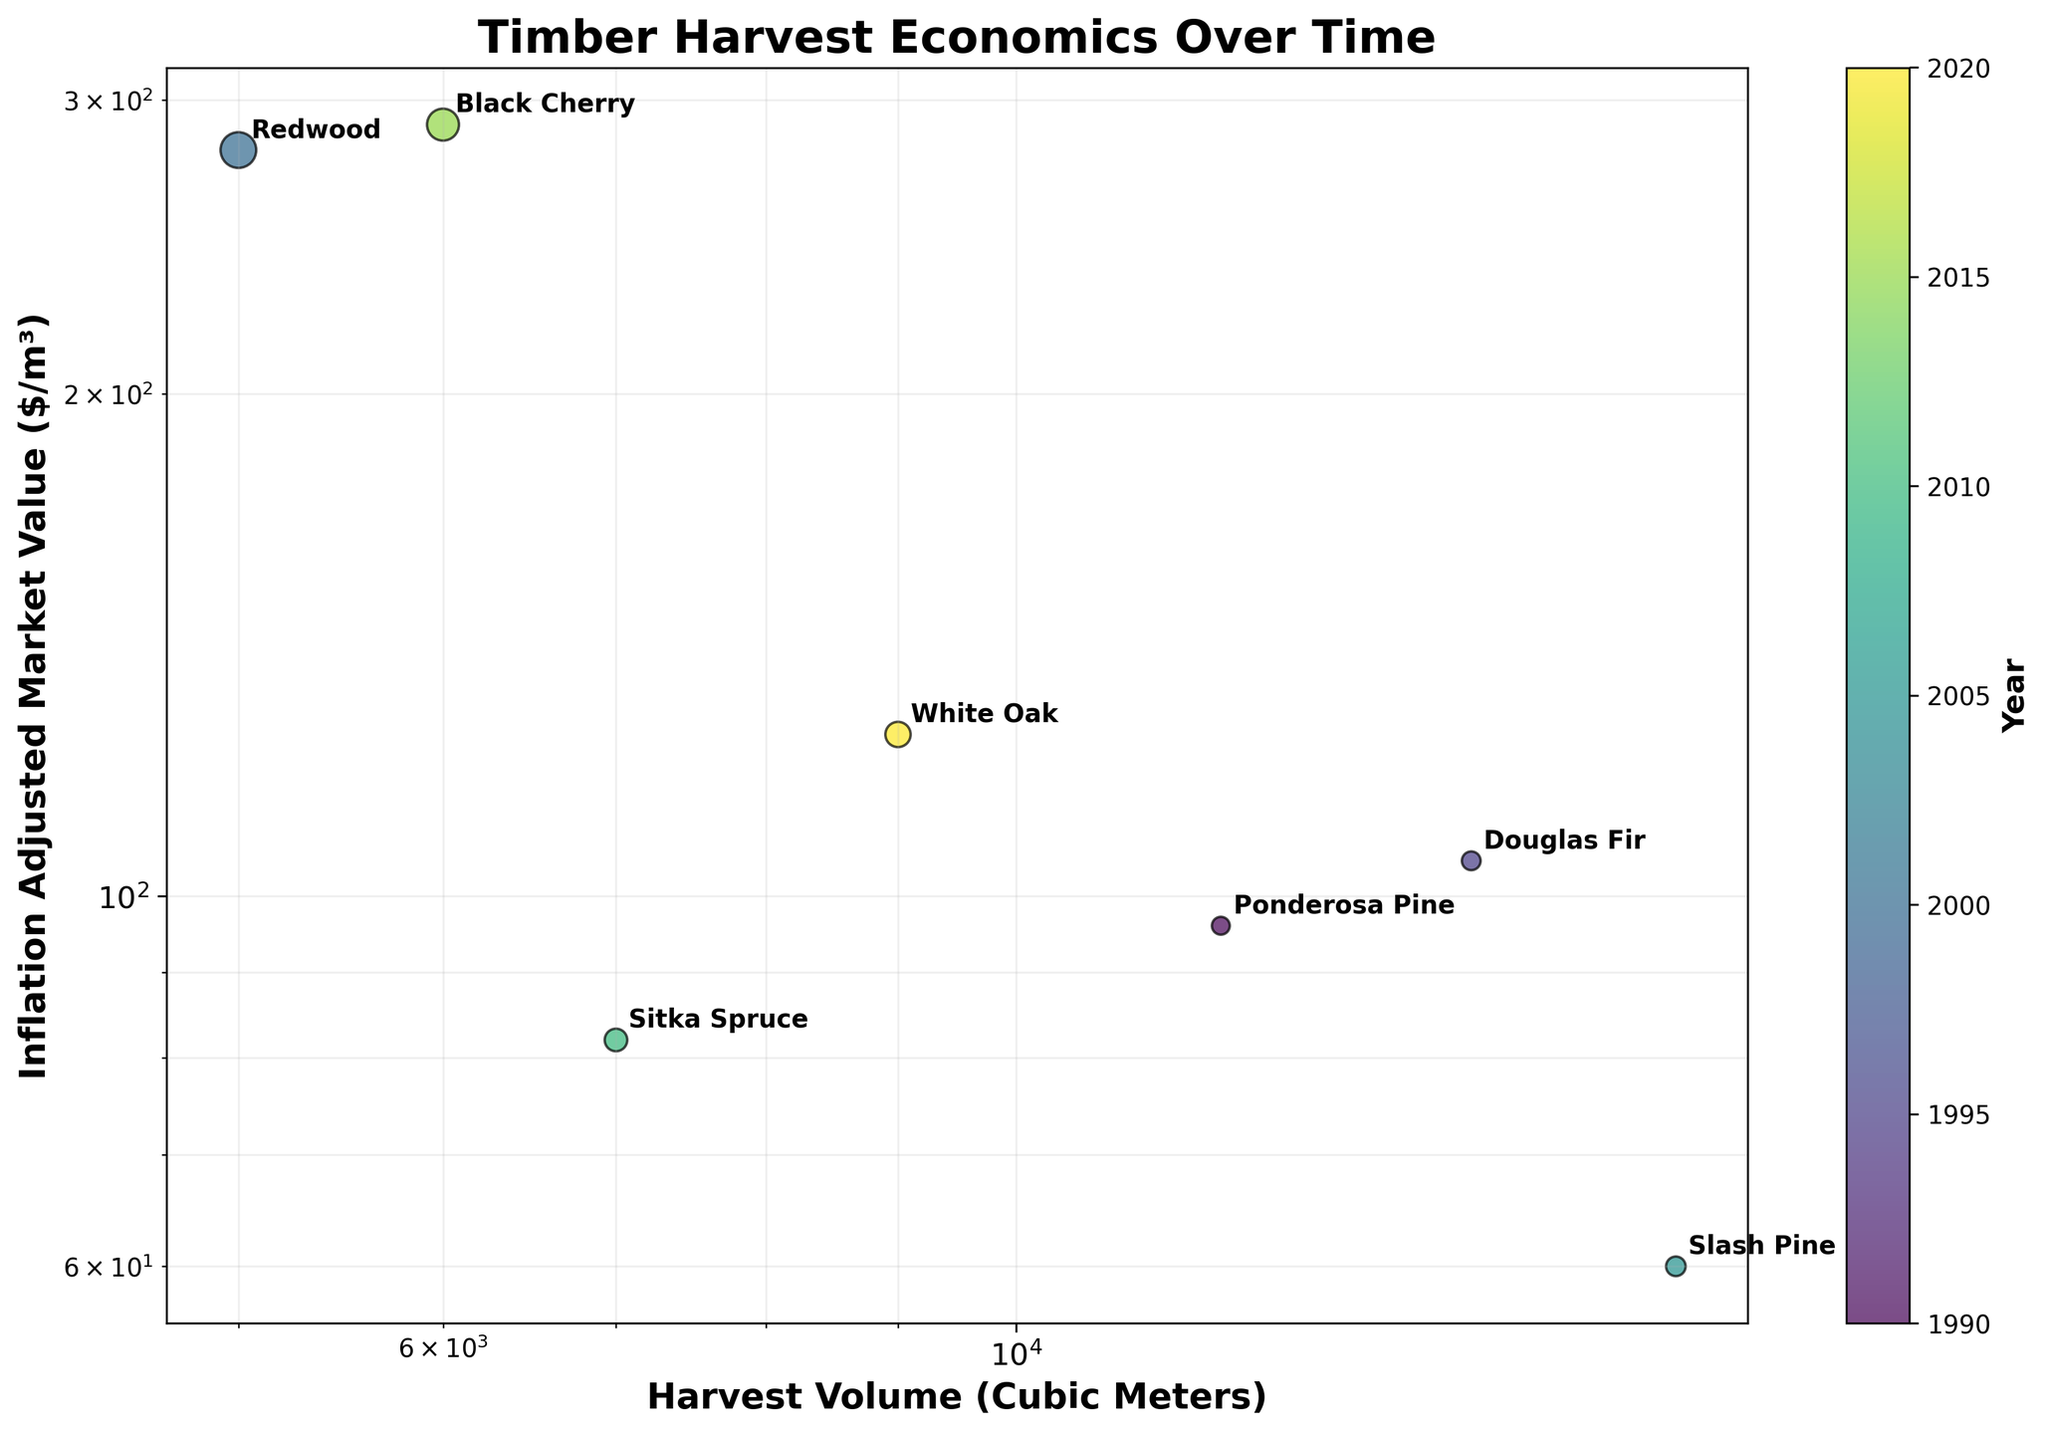What is the harvest volume of Ponderosa Pine? The harvest volume can be identified by finding the point labeled "Ponderosa Pine" on the x-axis, which represents "Harvest Volume (Cubic Meters)" with log scale.
Answer: 12000 Which species has the highest inflation-adjusted market value? By locating points along the y-axis labeled "Inflation Adjusted Market Value ($/m³)", the species with the highest value is identified by the furthest point up the log-scale. The label "Redwood" lies at the highest position.
Answer: Redwood How many species are shown in the plot? Each species is labeled on the scatter plot, so counting the unique labels gives the total number of species.
Answer: 7 Compare the inflation-adjusted market value of Douglas Fir and White Oak. Which one is higher? By locating the points labeled "Douglas Fir" and "White Oak" along the y-axis, we find Douglas Fir has a value around 105, and White Oak has 125.
Answer: White Oak What does the size of each point represent? Observing that different points vary in size and knowing it should correlate with a column in the data, the caption indicates larger circles represent higher "Conservation Cost".
Answer: Conservation Cost What is the trend in inflation-adjusted market value for timber species over the years? By examining the color-coded years on the scatter plot, we notice the inflation-adjusted market value fluctuates instead of showing a clear increasing or decreasing trend over time.
Answer: Fluctuates Calculate the average inflation-adjusted market value for all the species. To compute the average, add all values and divide by the number of species: (96 + 105 + 280 + 60 + 82 + 290 + 125) / 7 = 1038 / 7 = 148.
Answer: 148 What species is associated with the highest conservation cost? The largest scatter point on the plot represents the highest conservation cost, and this is annotated with the label "Redwood".
Answer: Redwood Which region has the smallest harvest volume? By looking at the points on the lower end of the x-axis, the smallest volume corresponds to "Redwood" in "California" with the smallest volume at 5000 cubic meters.
Answer: California Identify the species harvested in the Pacific Northwest. What is its inflation-adjusted market value? By locating the species annotated "Douglas Fir" and cross-referencing with its y-position, the inflation-adjusted market value is around 105.
Answer: Douglas Fir, 105 